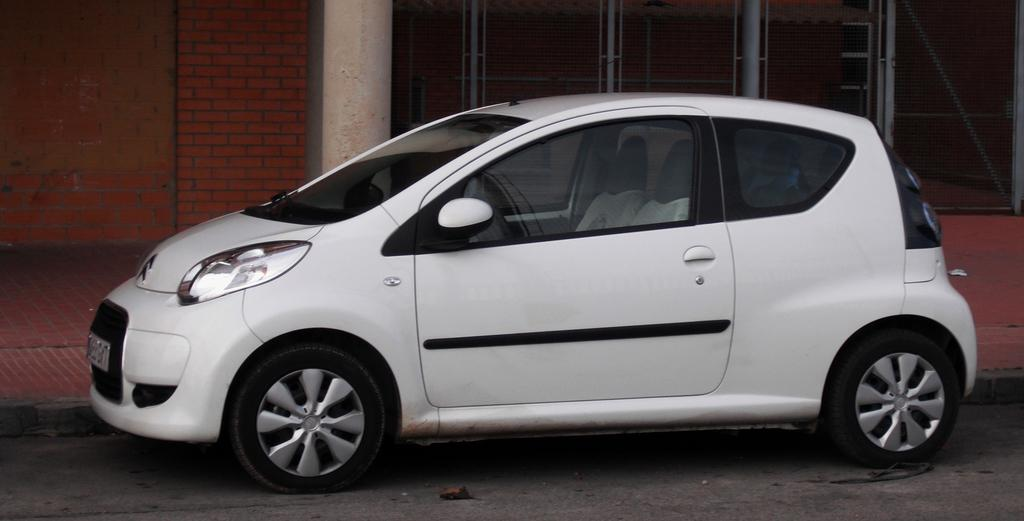What color is the car in the image? The car in the image is white. Where is the car located in the image? The car is on the road in the image. What can be seen in the background of the image? There are pillars, a brick wall, and a fence in the background of the image. How many songs can be heard coming from the turkey in the image? There is no turkey present in the image, and therefore no songs can be heard. 